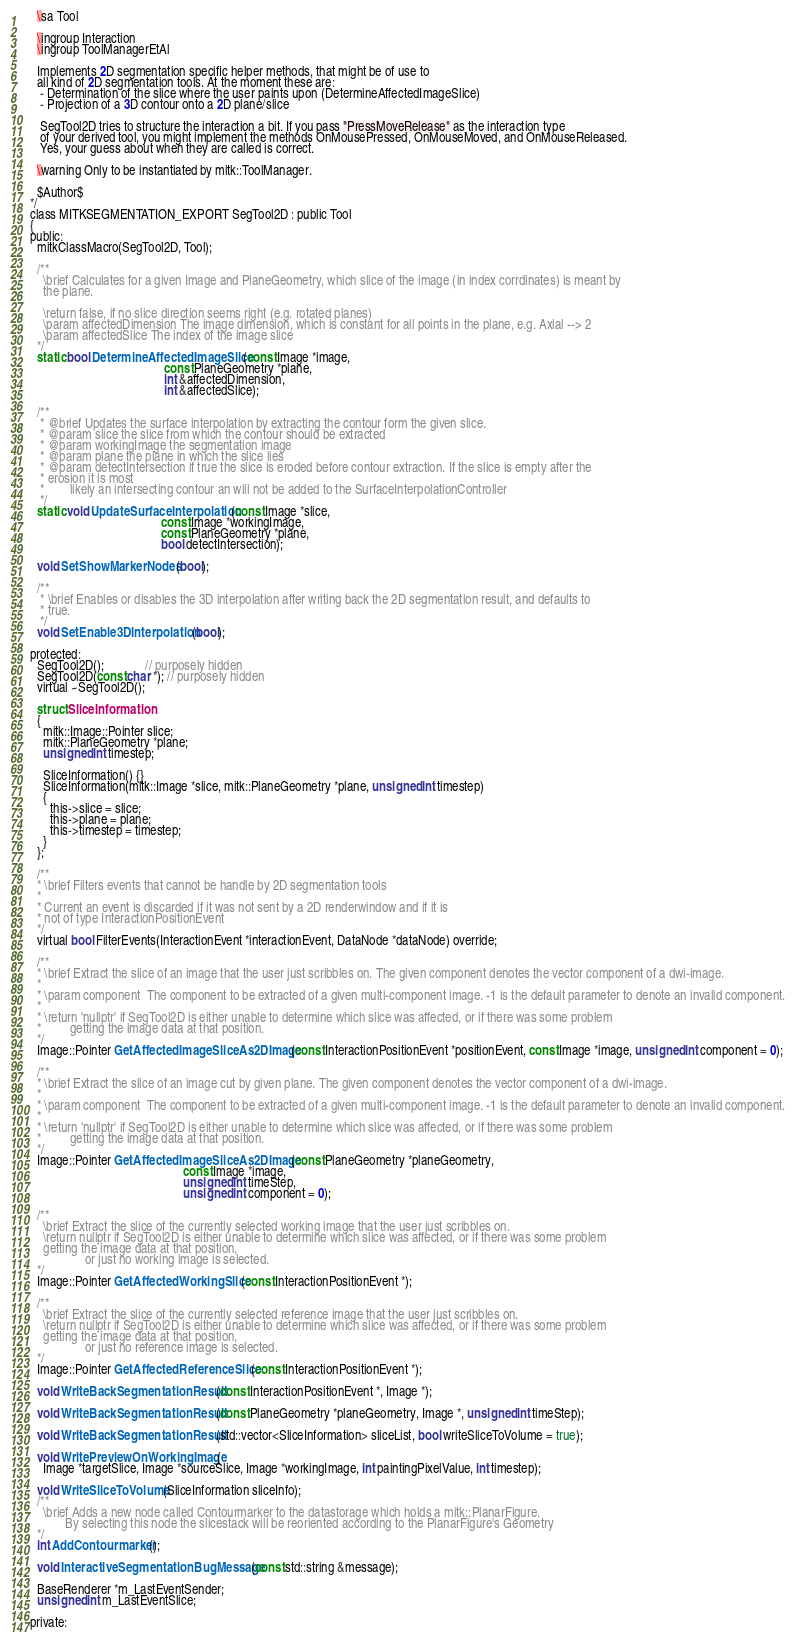<code> <loc_0><loc_0><loc_500><loc_500><_C_>
    \sa Tool

    \ingroup Interaction
    \ingroup ToolManagerEtAl

    Implements 2D segmentation specific helper methods, that might be of use to
    all kind of 2D segmentation tools. At the moment these are:
     - Determination of the slice where the user paints upon (DetermineAffectedImageSlice)
     - Projection of a 3D contour onto a 2D plane/slice

     SegTool2D tries to structure the interaction a bit. If you pass "PressMoveRelease" as the interaction type
     of your derived tool, you might implement the methods OnMousePressed, OnMouseMoved, and OnMouseReleased.
     Yes, your guess about when they are called is correct.

    \warning Only to be instantiated by mitk::ToolManager.

    $Author$
  */
  class MITKSEGMENTATION_EXPORT SegTool2D : public Tool
  {
  public:
    mitkClassMacro(SegTool2D, Tool);

    /**
      \brief Calculates for a given Image and PlaneGeometry, which slice of the image (in index corrdinates) is meant by
      the plane.

      \return false, if no slice direction seems right (e.g. rotated planes)
      \param affectedDimension The image dimension, which is constant for all points in the plane, e.g. Axial --> 2
      \param affectedSlice The index of the image slice
    */
    static bool DetermineAffectedImageSlice(const Image *image,
                                            const PlaneGeometry *plane,
                                            int &affectedDimension,
                                            int &affectedSlice);

    /**
     * @brief Updates the surface interpolation by extracting the contour form the given slice.
     * @param slice the slice from which the contour should be extracted
     * @param workingImage the segmentation image
     * @param plane the plane in which the slice lies
     * @param detectIntersection if true the slice is eroded before contour extraction. If the slice is empty after the
     * erosion it is most
     *        likely an intersecting contour an will not be added to the SurfaceInterpolationController
     */
    static void UpdateSurfaceInterpolation(const Image *slice,
                                           const Image *workingImage,
                                           const PlaneGeometry *plane,
                                           bool detectIntersection);

    void SetShowMarkerNodes(bool);

    /**
     * \brief Enables or disables the 3D interpolation after writing back the 2D segmentation result, and defaults to
     * true.
     */
    void SetEnable3DInterpolation(bool);

  protected:
    SegTool2D();             // purposely hidden
    SegTool2D(const char *); // purposely hidden
    virtual ~SegTool2D();

    struct SliceInformation
    {
      mitk::Image::Pointer slice;
      mitk::PlaneGeometry *plane;
      unsigned int timestep;

      SliceInformation() {}
      SliceInformation(mitk::Image *slice, mitk::PlaneGeometry *plane, unsigned int timestep)
      {
        this->slice = slice;
        this->plane = plane;
        this->timestep = timestep;
      }
    };

    /**
    * \brief Filters events that cannot be handle by 2D segmentation tools
    *
    * Current an event is discarded if it was not sent by a 2D renderwindow and if it is
    * not of type InteractionPositionEvent
    */
    virtual bool FilterEvents(InteractionEvent *interactionEvent, DataNode *dataNode) override;

    /**
    * \brief Extract the slice of an image that the user just scribbles on. The given component denotes the vector component of a dwi-image.
    *
    * \param component  The component to be extracted of a given multi-component image. -1 is the default parameter to denote an invalid component.
    *
    * \return 'nullptr' if SegTool2D is either unable to determine which slice was affected, or if there was some problem
    *         getting the image data at that position.
    */
    Image::Pointer GetAffectedImageSliceAs2DImage(const InteractionPositionEvent *positionEvent, const Image *image, unsigned int component = 0);

    /**
    * \brief Extract the slice of an image cut by given plane. The given component denotes the vector component of a dwi-image.
    *
    * \param component  The component to be extracted of a given multi-component image. -1 is the default parameter to denote an invalid component.
    *
    * \return 'nullptr' if SegTool2D is either unable to determine which slice was affected, or if there was some problem
    *         getting the image data at that position.
    */
    Image::Pointer GetAffectedImageSliceAs2DImage(const PlaneGeometry *planeGeometry,
                                                  const Image *image,
                                                  unsigned int timeStep,
                                                  unsigned int component = 0);

    /**
      \brief Extract the slice of the currently selected working image that the user just scribbles on.
      \return nullptr if SegTool2D is either unable to determine which slice was affected, or if there was some problem
      getting the image data at that position,
                   or just no working image is selected.
    */
    Image::Pointer GetAffectedWorkingSlice(const InteractionPositionEvent *);

    /**
      \brief Extract the slice of the currently selected reference image that the user just scribbles on.
      \return nullptr if SegTool2D is either unable to determine which slice was affected, or if there was some problem
      getting the image data at that position,
                   or just no reference image is selected.
    */
    Image::Pointer GetAffectedReferenceSlice(const InteractionPositionEvent *);

    void WriteBackSegmentationResult(const InteractionPositionEvent *, Image *);

    void WriteBackSegmentationResult(const PlaneGeometry *planeGeometry, Image *, unsigned int timeStep);

    void WriteBackSegmentationResult(std::vector<SliceInformation> sliceList, bool writeSliceToVolume = true);

    void WritePreviewOnWorkingImage(
      Image *targetSlice, Image *sourceSlice, Image *workingImage, int paintingPixelValue, int timestep);

    void WriteSliceToVolume(SliceInformation sliceInfo);
    /**
      \brief Adds a new node called Contourmarker to the datastorage which holds a mitk::PlanarFigure.
             By selecting this node the slicestack will be reoriented according to the PlanarFigure's Geometry
    */
    int AddContourmarker();

    void InteractiveSegmentationBugMessage(const std::string &message);

    BaseRenderer *m_LastEventSender;
    unsigned int m_LastEventSlice;

  private:</code> 